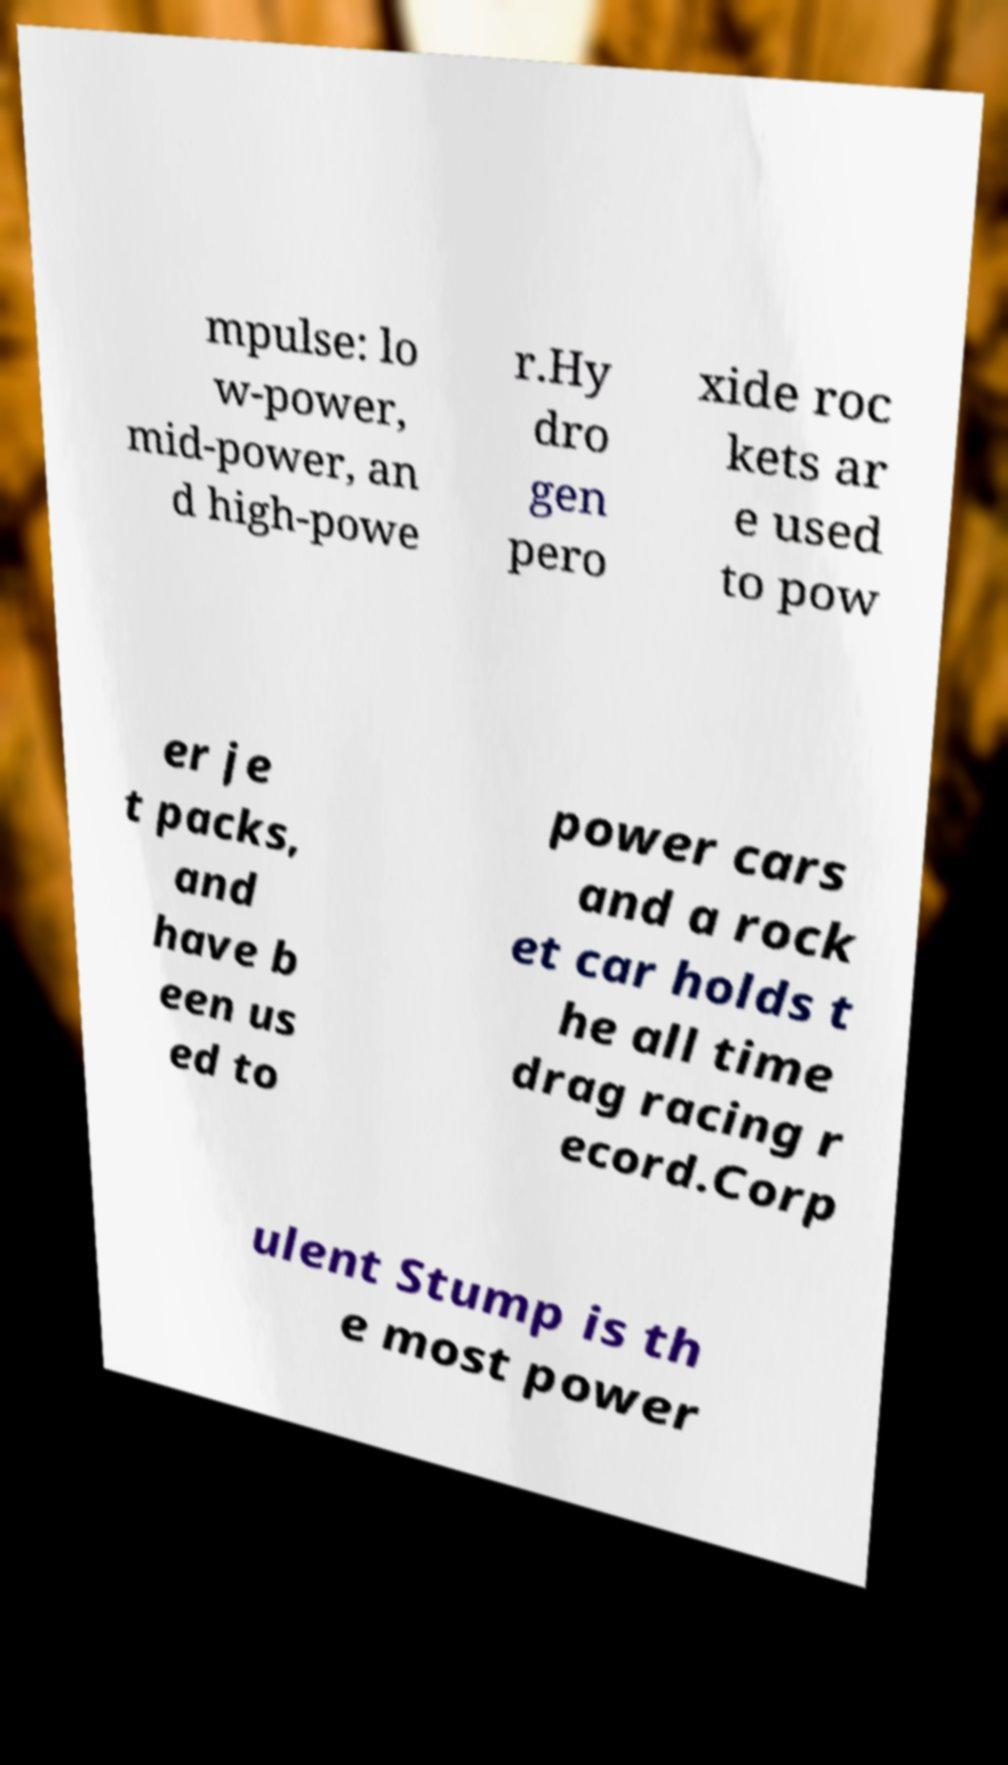I need the written content from this picture converted into text. Can you do that? mpulse: lo w-power, mid-power, an d high-powe r.Hy dro gen pero xide roc kets ar e used to pow er je t packs, and have b een us ed to power cars and a rock et car holds t he all time drag racing r ecord.Corp ulent Stump is th e most power 